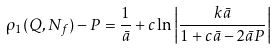<formula> <loc_0><loc_0><loc_500><loc_500>\rho _ { 1 } ( Q , N _ { f } ) - P = \frac { 1 } { \bar { a } } + c \ln \left | \frac { k \bar { a } } { 1 + c \bar { a } - 2 \bar { a } P } \right |</formula> 